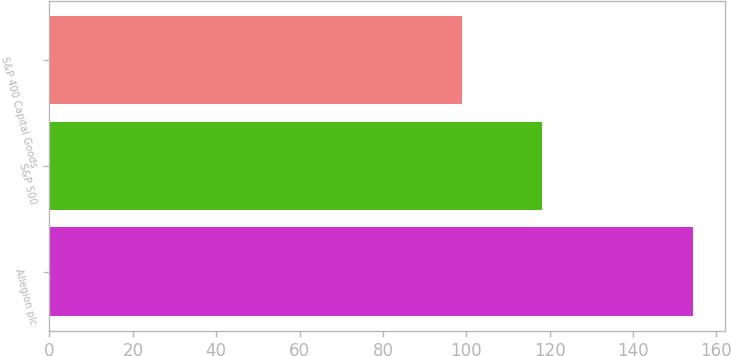Convert chart. <chart><loc_0><loc_0><loc_500><loc_500><bar_chart><fcel>Allegion plc<fcel>S&P 500<fcel>S&P 400 Capital Goods<nl><fcel>154.37<fcel>118.18<fcel>99.07<nl></chart> 